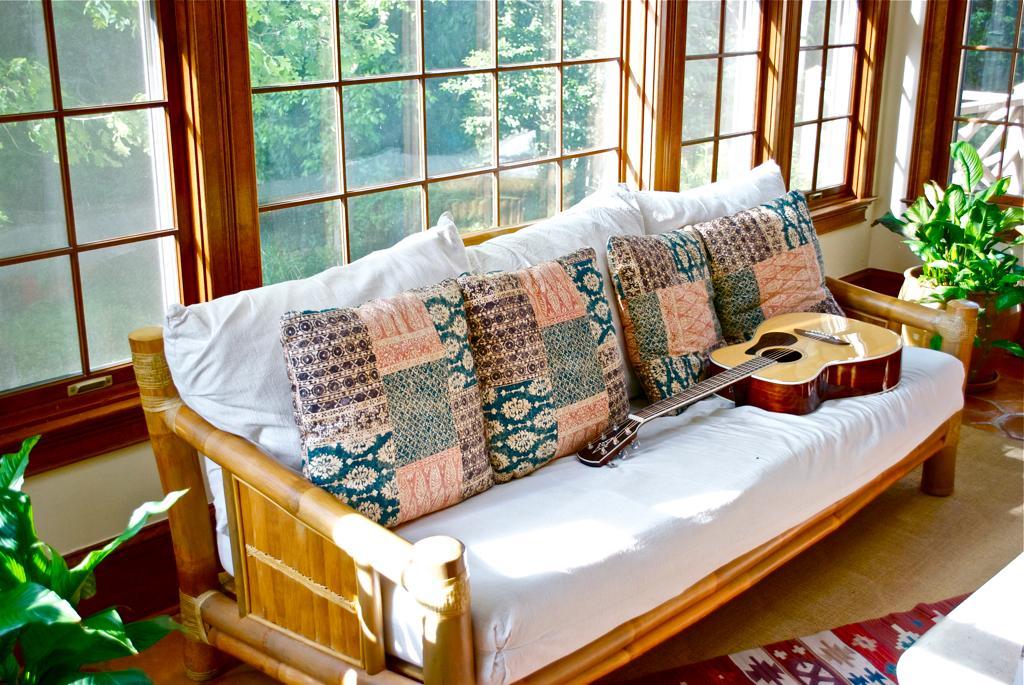Could you give a brief overview of what you see in this image? In this image there is a sofa having different coloured cushions and a guitar on it. To the right side of the image there is a pot and a plant. Back side of the sofa there is a window. There are trees at the background of the image. A carpet is on the floor. 